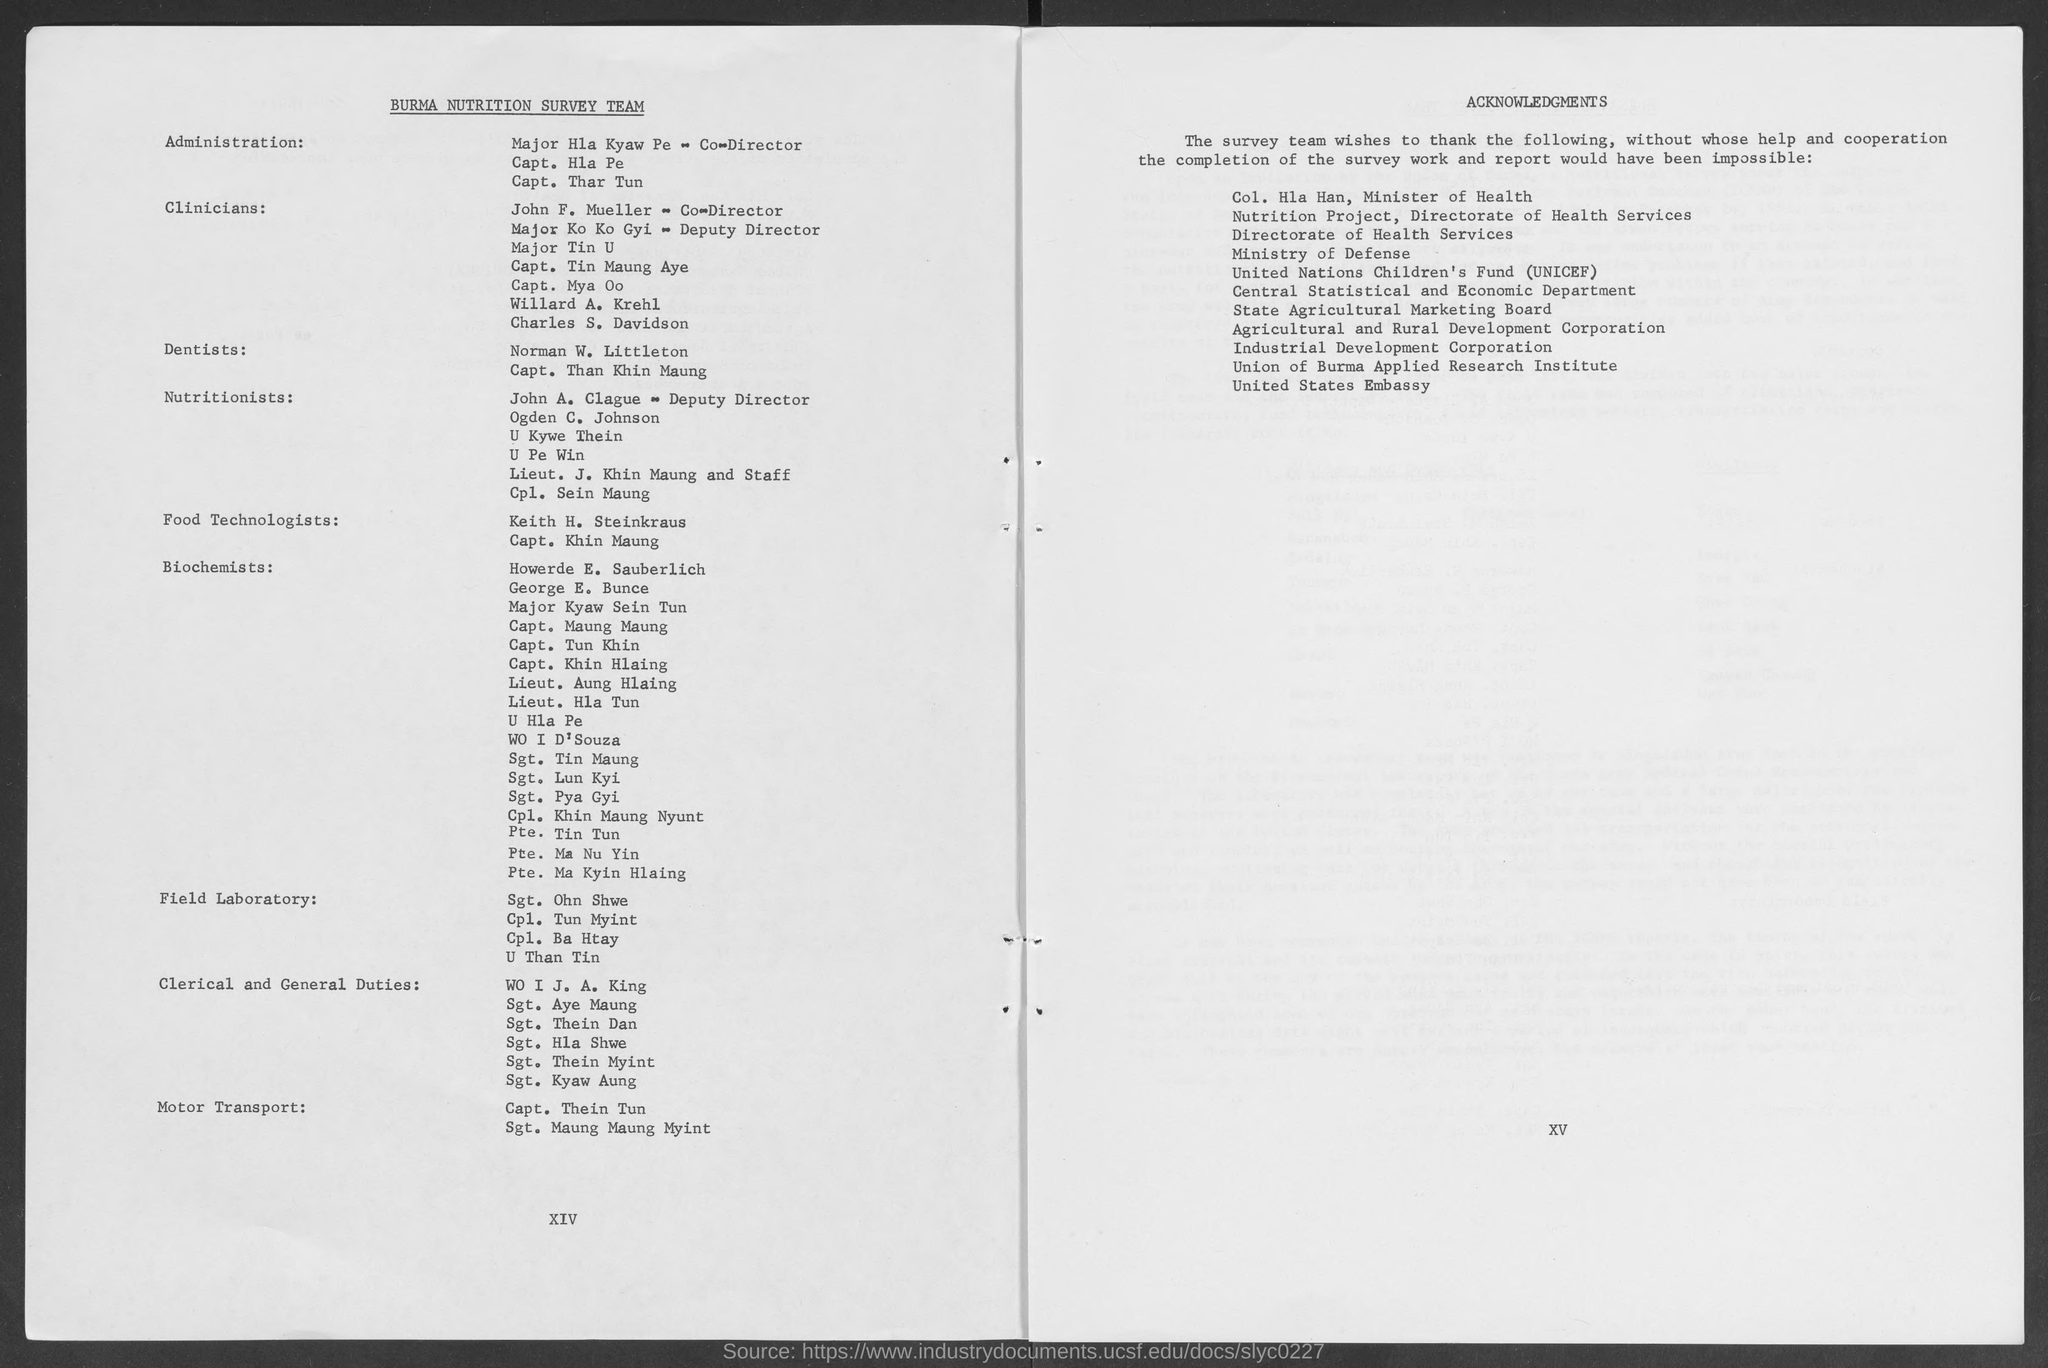Draw attention to some important aspects in this diagram. The heading at the top of the left page is "Burma Nutrition Survey Team. UNICEF, which stands for the United Nations Children's Fund, is an organization dedicated to promoting and protecting the rights of children worldwide. The heading at the top of the right page is 'Acknowledgements.' 